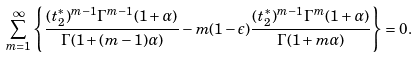<formula> <loc_0><loc_0><loc_500><loc_500>\sum _ { m = 1 } ^ { \infty } \left \{ \frac { ( t _ { 2 } ^ { * } ) ^ { m - 1 } \Gamma ^ { m - 1 } ( 1 + \alpha ) } { \Gamma ( 1 + ( m - 1 ) \alpha ) } - m ( 1 - \epsilon ) \frac { ( t _ { 2 } ^ { * } ) ^ { m - 1 } \Gamma ^ { m } ( 1 + \alpha ) } { \Gamma ( 1 + m \alpha ) } \right \} = 0 .</formula> 